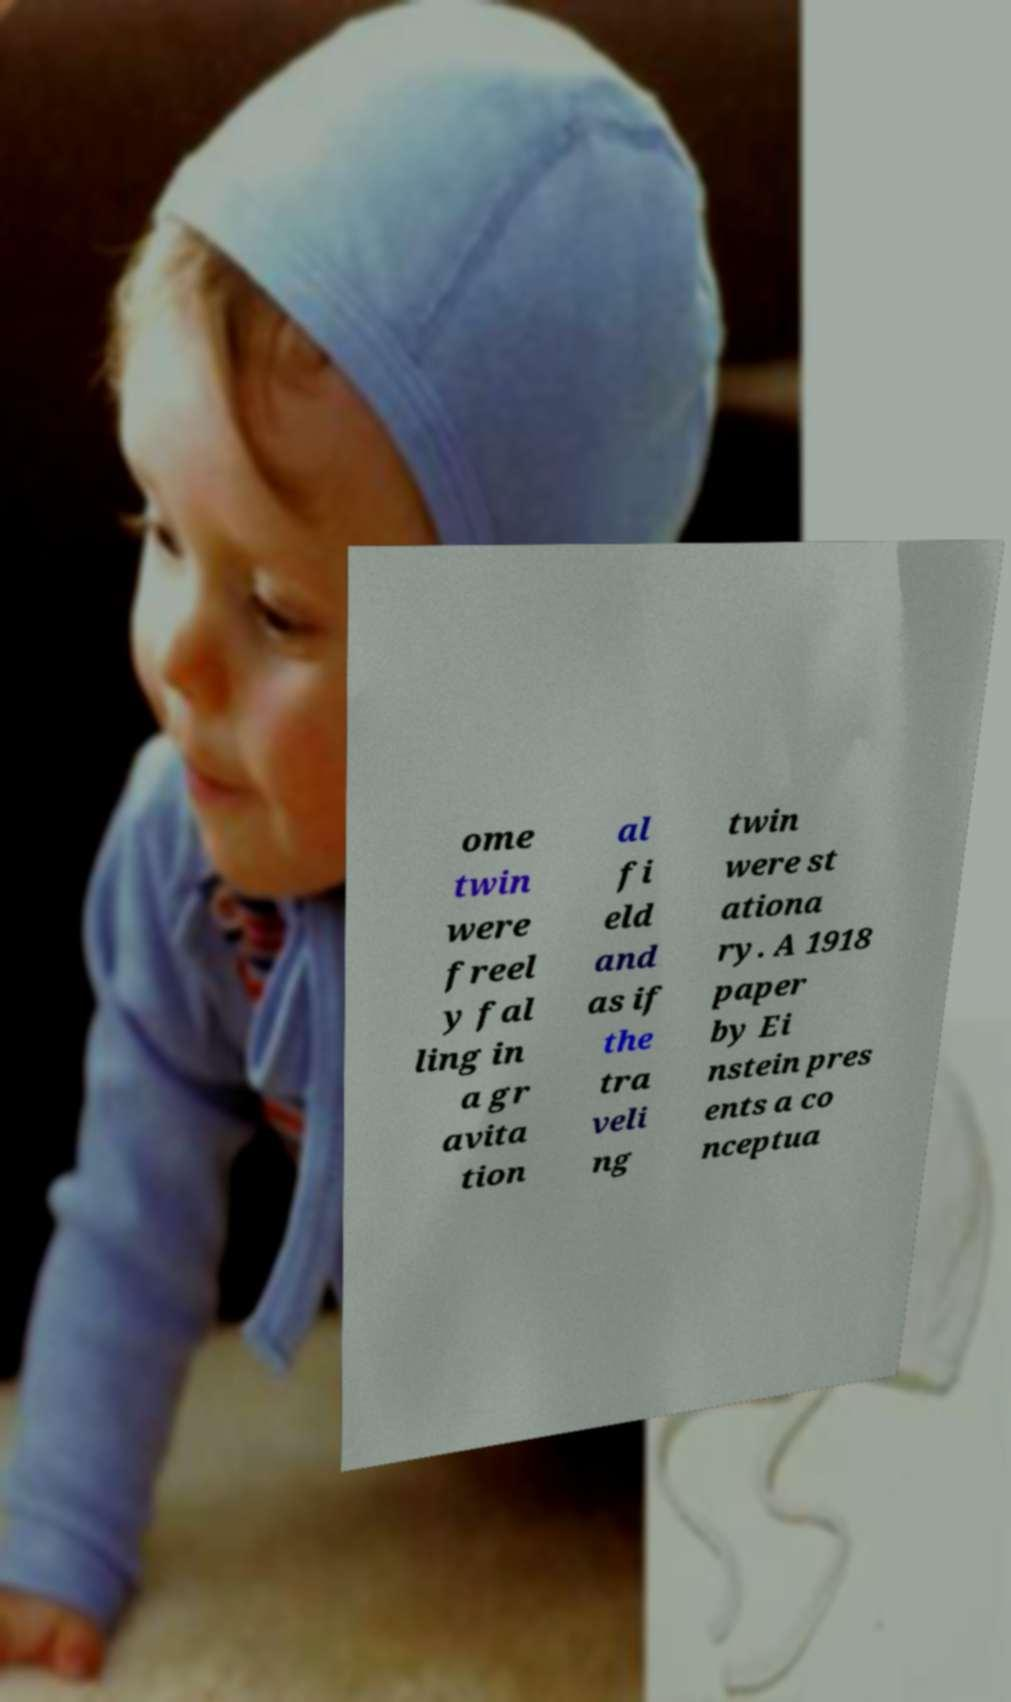Could you assist in decoding the text presented in this image and type it out clearly? ome twin were freel y fal ling in a gr avita tion al fi eld and as if the tra veli ng twin were st ationa ry. A 1918 paper by Ei nstein pres ents a co nceptua 